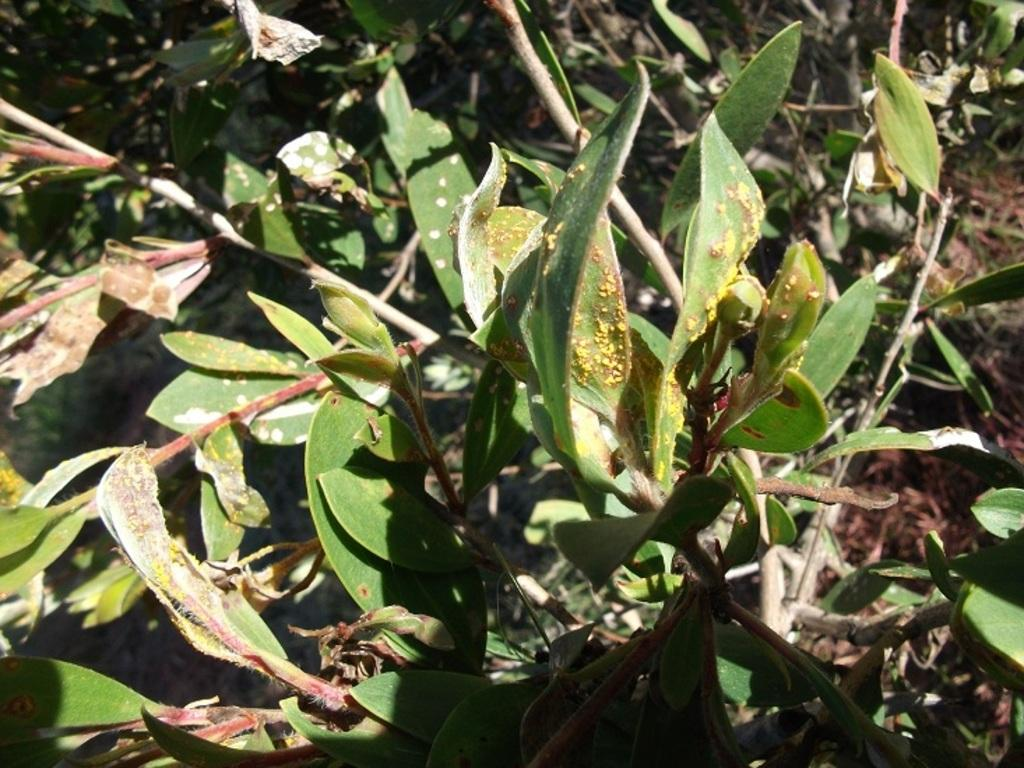What type of plants can be seen in the image? There are green plants in the image. What can be found on the ground in the image? There are leaves on the ground in the image. What grade is the student receiving in the image? There is no student or grade present in the image; it features green plants and leaves on the ground. What type of ear is visible on the plant in the image? There is no ear visible on any plant in the image; it only shows green plants and leaves on the ground. 